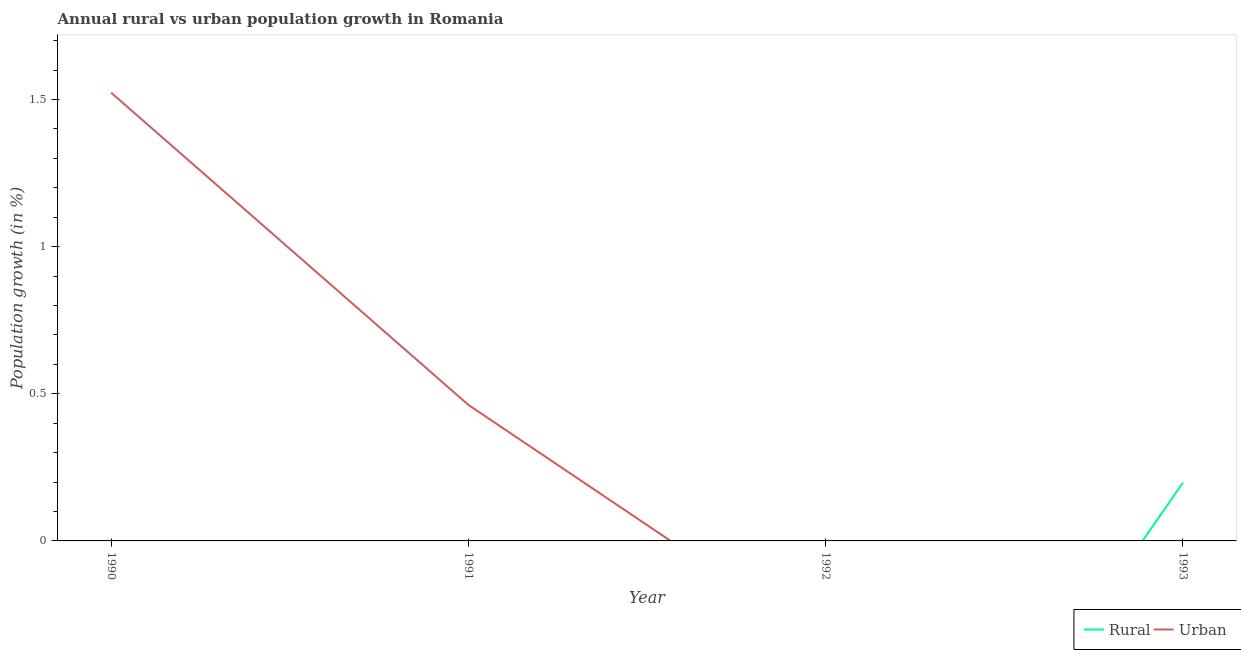Is the number of lines equal to the number of legend labels?
Your response must be concise. No. What is the rural population growth in 1991?
Keep it short and to the point. 0. Across all years, what is the maximum urban population growth?
Offer a very short reply. 1.52. Across all years, what is the minimum rural population growth?
Provide a succinct answer. 0. What is the total rural population growth in the graph?
Make the answer very short. 0.2. What is the difference between the rural population growth in 1993 and the urban population growth in 1992?
Make the answer very short. 0.2. What is the average rural population growth per year?
Offer a terse response. 0.05. What is the difference between the highest and the lowest urban population growth?
Ensure brevity in your answer.  1.52. In how many years, is the urban population growth greater than the average urban population growth taken over all years?
Provide a succinct answer. 1. Is the rural population growth strictly greater than the urban population growth over the years?
Ensure brevity in your answer.  No. How many lines are there?
Provide a short and direct response. 2. How many years are there in the graph?
Make the answer very short. 4. What is the difference between two consecutive major ticks on the Y-axis?
Your answer should be very brief. 0.5. Are the values on the major ticks of Y-axis written in scientific E-notation?
Give a very brief answer. No. Does the graph contain any zero values?
Provide a succinct answer. Yes. Does the graph contain grids?
Offer a very short reply. No. Where does the legend appear in the graph?
Offer a terse response. Bottom right. How many legend labels are there?
Offer a terse response. 2. What is the title of the graph?
Keep it short and to the point. Annual rural vs urban population growth in Romania. Does "Rural Population" appear as one of the legend labels in the graph?
Ensure brevity in your answer.  No. What is the label or title of the X-axis?
Your response must be concise. Year. What is the label or title of the Y-axis?
Ensure brevity in your answer.  Population growth (in %). What is the Population growth (in %) of Urban  in 1990?
Offer a terse response. 1.52. What is the Population growth (in %) of Rural in 1991?
Your answer should be very brief. 0. What is the Population growth (in %) of Urban  in 1991?
Your response must be concise. 0.46. What is the Population growth (in %) in Urban  in 1992?
Provide a succinct answer. 0. What is the Population growth (in %) in Rural in 1993?
Keep it short and to the point. 0.2. Across all years, what is the maximum Population growth (in %) in Rural?
Provide a short and direct response. 0.2. Across all years, what is the maximum Population growth (in %) in Urban ?
Your answer should be very brief. 1.52. Across all years, what is the minimum Population growth (in %) of Rural?
Make the answer very short. 0. What is the total Population growth (in %) of Rural in the graph?
Provide a succinct answer. 0.2. What is the total Population growth (in %) in Urban  in the graph?
Keep it short and to the point. 1.99. What is the difference between the Population growth (in %) in Urban  in 1990 and that in 1991?
Make the answer very short. 1.06. What is the average Population growth (in %) of Rural per year?
Make the answer very short. 0.05. What is the average Population growth (in %) in Urban  per year?
Make the answer very short. 0.5. What is the ratio of the Population growth (in %) of Urban  in 1990 to that in 1991?
Offer a very short reply. 3.3. What is the difference between the highest and the lowest Population growth (in %) of Rural?
Provide a short and direct response. 0.2. What is the difference between the highest and the lowest Population growth (in %) of Urban ?
Offer a very short reply. 1.52. 